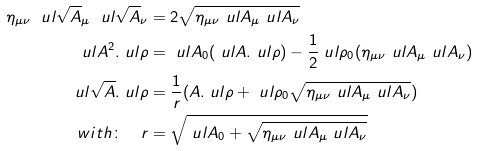Convert formula to latex. <formula><loc_0><loc_0><loc_500><loc_500>\eta _ { \mu \nu } \ u l { \sqrt { A } } _ { \mu } \ u l { \sqrt { A } } _ { \nu } & = 2 \sqrt { \eta _ { \mu \nu } \ u l A _ { \mu } \ u l A _ { \nu } } \\ \ u l A ^ { 2 } . \ u l \rho & = \ u l A _ { 0 } ( \ u l A . \ u l \rho ) - \frac { 1 } { 2 } \ u l \rho _ { 0 } ( \eta _ { \mu \nu } \ u l A _ { \mu } \ u l A _ { \nu } ) \\ \ u l { \sqrt { A } } . \ u l \rho & = \frac { 1 } { r } ( A . \ u l \rho + \ u l \rho _ { 0 } \sqrt { \eta _ { \mu \nu } \ u l A _ { \mu } \ u l A _ { \nu } } ) \\ w i t h \colon \quad r & = \sqrt { \ u l A _ { 0 } + \sqrt { \eta _ { \mu \nu } \ u l A _ { \mu } \ u l A _ { \nu } } } \\</formula> 